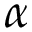Convert formula to latex. <formula><loc_0><loc_0><loc_500><loc_500>\alpha</formula> 